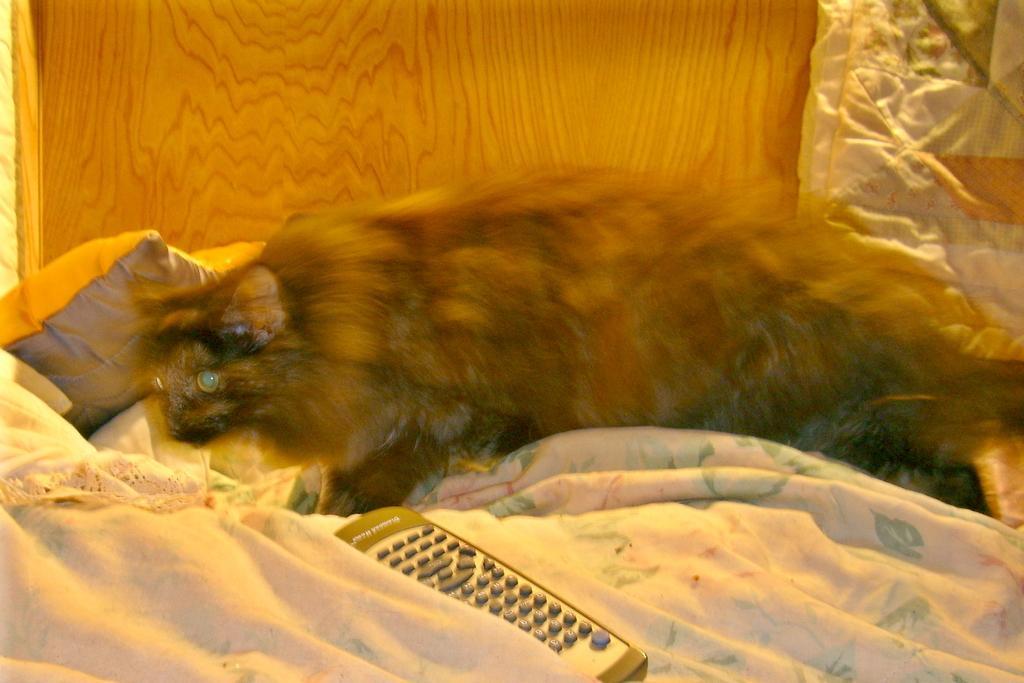Please provide a concise description of this image. In this image we can see an animal on the bed, also we can see a pillow and a remote, in the background we can see the wall. 